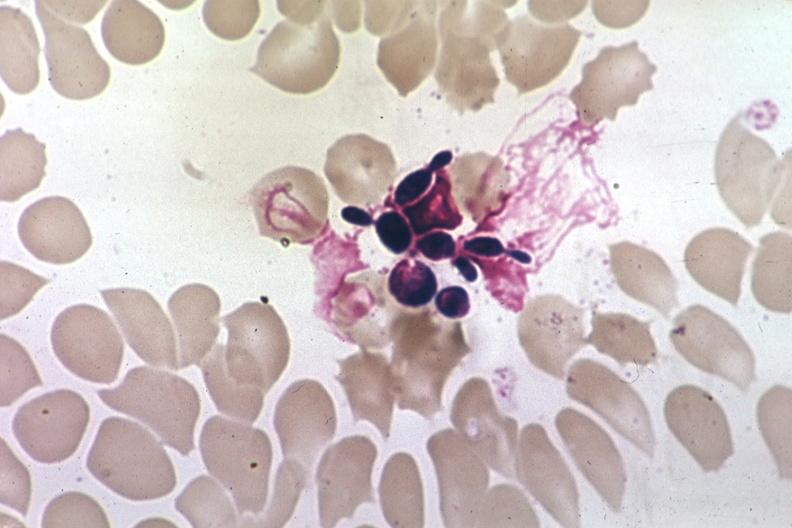s hematologic present?
Answer the question using a single word or phrase. Yes 